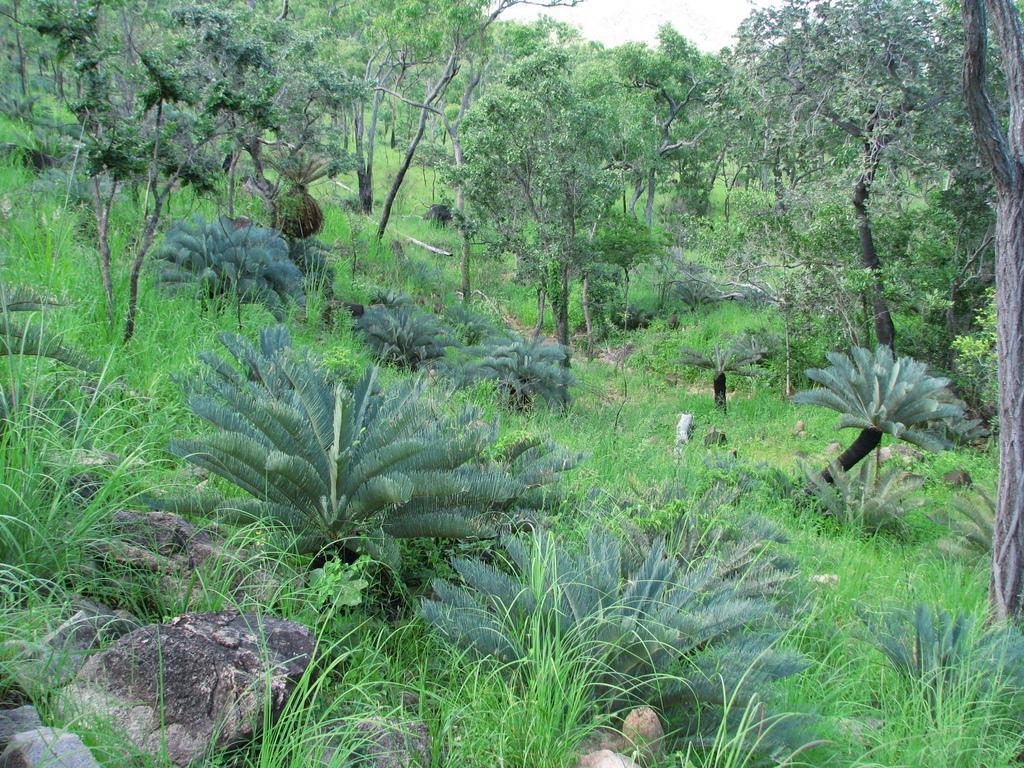Describe this image in one or two sentences. This image is taken in a forest. There are many trees. Grass and also rocks are visible in this image. Sky is also present. 